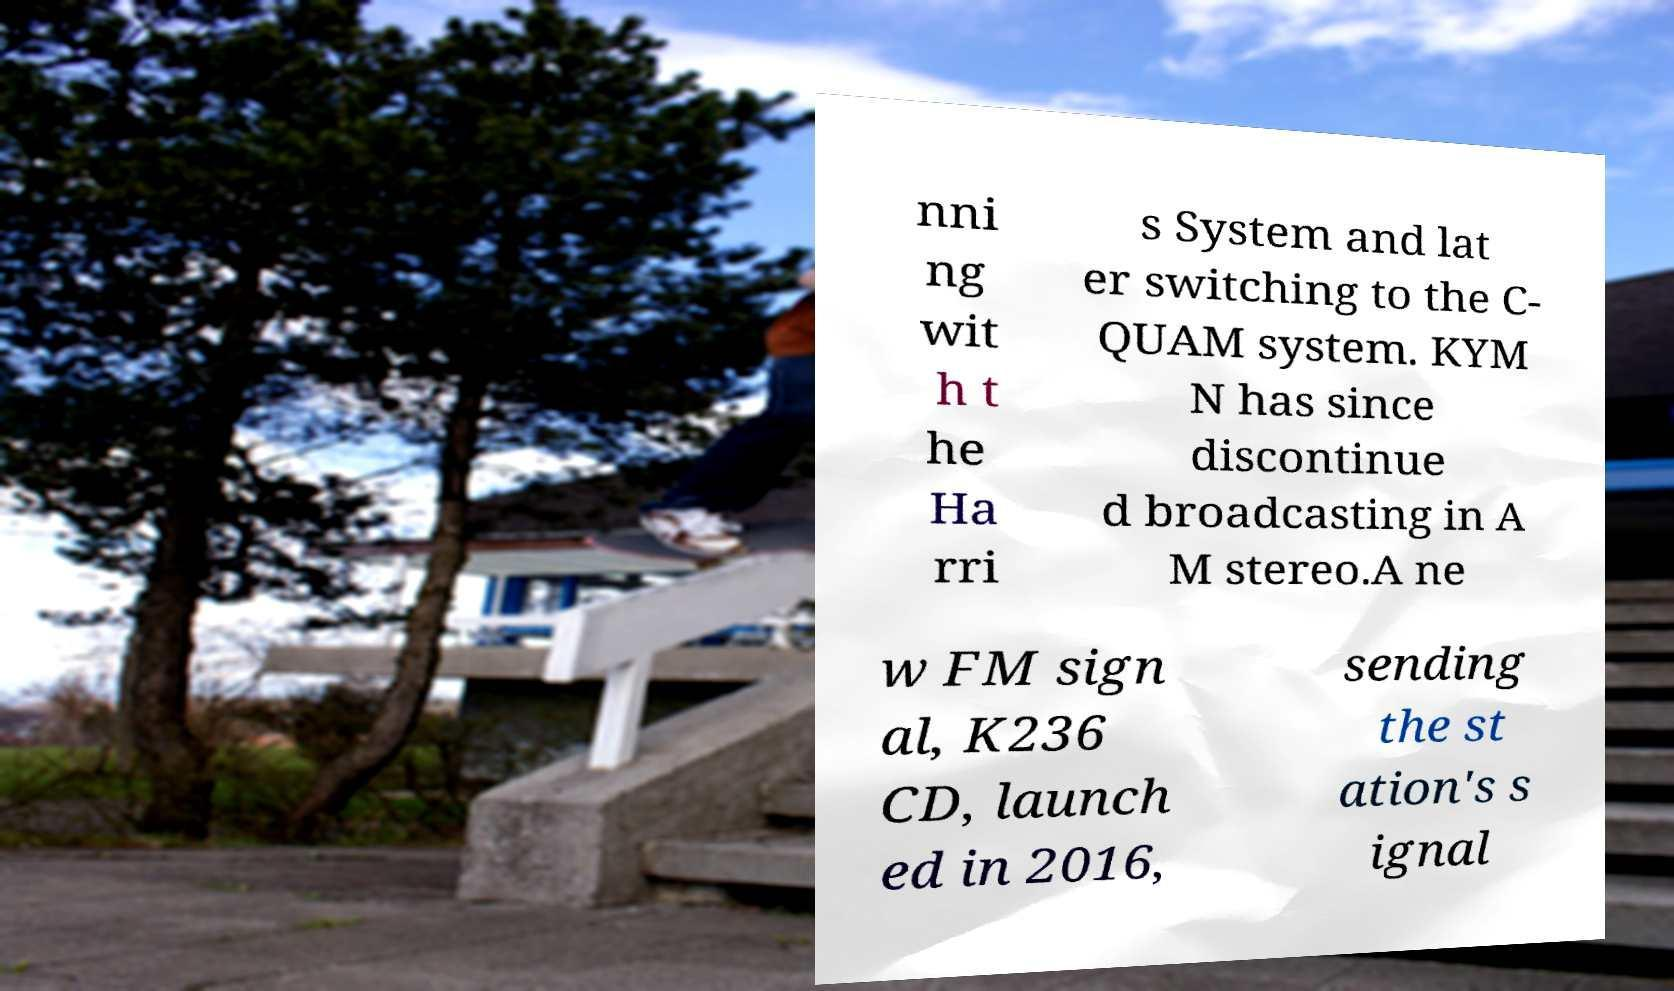Can you read and provide the text displayed in the image?This photo seems to have some interesting text. Can you extract and type it out for me? nni ng wit h t he Ha rri s System and lat er switching to the C- QUAM system. KYM N has since discontinue d broadcasting in A M stereo.A ne w FM sign al, K236 CD, launch ed in 2016, sending the st ation's s ignal 